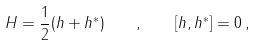Convert formula to latex. <formula><loc_0><loc_0><loc_500><loc_500>H = \frac { 1 } { 2 } ( h + h ^ { * } ) \quad , \quad \left [ h , h ^ { * } \right ] = 0 \, ,</formula> 